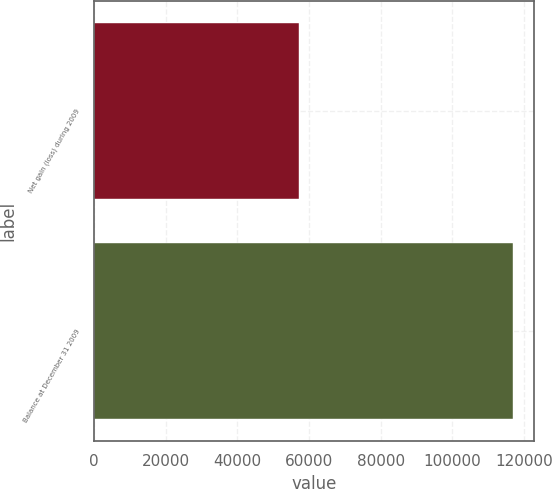Convert chart to OTSL. <chart><loc_0><loc_0><loc_500><loc_500><bar_chart><fcel>Net gain (loss) during 2009<fcel>Balance at December 31 2009<nl><fcel>57284<fcel>117046<nl></chart> 